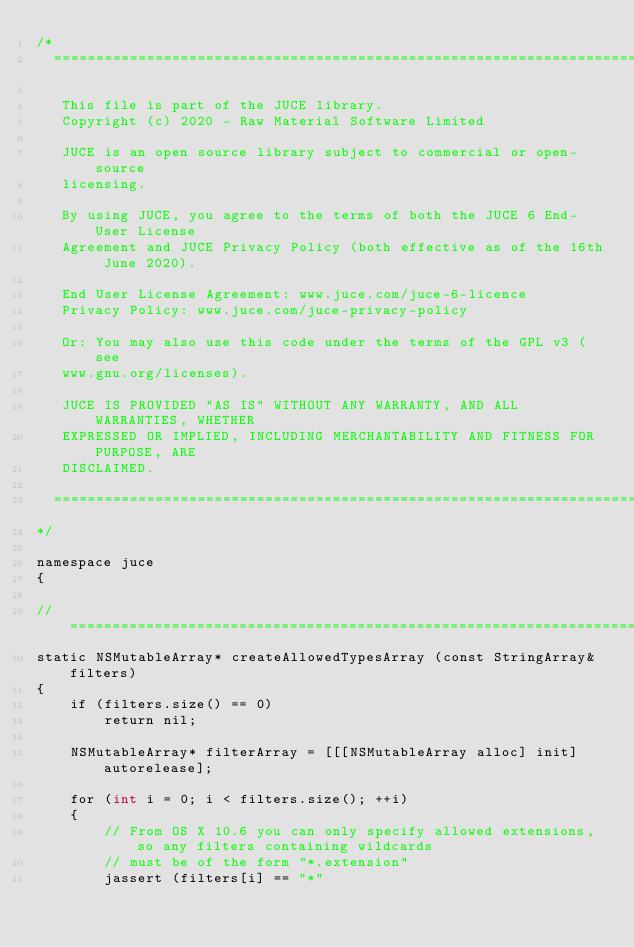<code> <loc_0><loc_0><loc_500><loc_500><_ObjectiveC_>/*
  ==============================================================================

   This file is part of the JUCE library.
   Copyright (c) 2020 - Raw Material Software Limited

   JUCE is an open source library subject to commercial or open-source
   licensing.

   By using JUCE, you agree to the terms of both the JUCE 6 End-User License
   Agreement and JUCE Privacy Policy (both effective as of the 16th June 2020).

   End User License Agreement: www.juce.com/juce-6-licence
   Privacy Policy: www.juce.com/juce-privacy-policy

   Or: You may also use this code under the terms of the GPL v3 (see
   www.gnu.org/licenses).

   JUCE IS PROVIDED "AS IS" WITHOUT ANY WARRANTY, AND ALL WARRANTIES, WHETHER
   EXPRESSED OR IMPLIED, INCLUDING MERCHANTABILITY AND FITNESS FOR PURPOSE, ARE
   DISCLAIMED.

  ==============================================================================
*/

namespace juce
{

//==============================================================================
static NSMutableArray* createAllowedTypesArray (const StringArray& filters)
{
    if (filters.size() == 0)
        return nil;

    NSMutableArray* filterArray = [[[NSMutableArray alloc] init] autorelease];

    for (int i = 0; i < filters.size(); ++i)
    {
        // From OS X 10.6 you can only specify allowed extensions, so any filters containing wildcards
        // must be of the form "*.extension"
        jassert (filters[i] == "*"</code> 